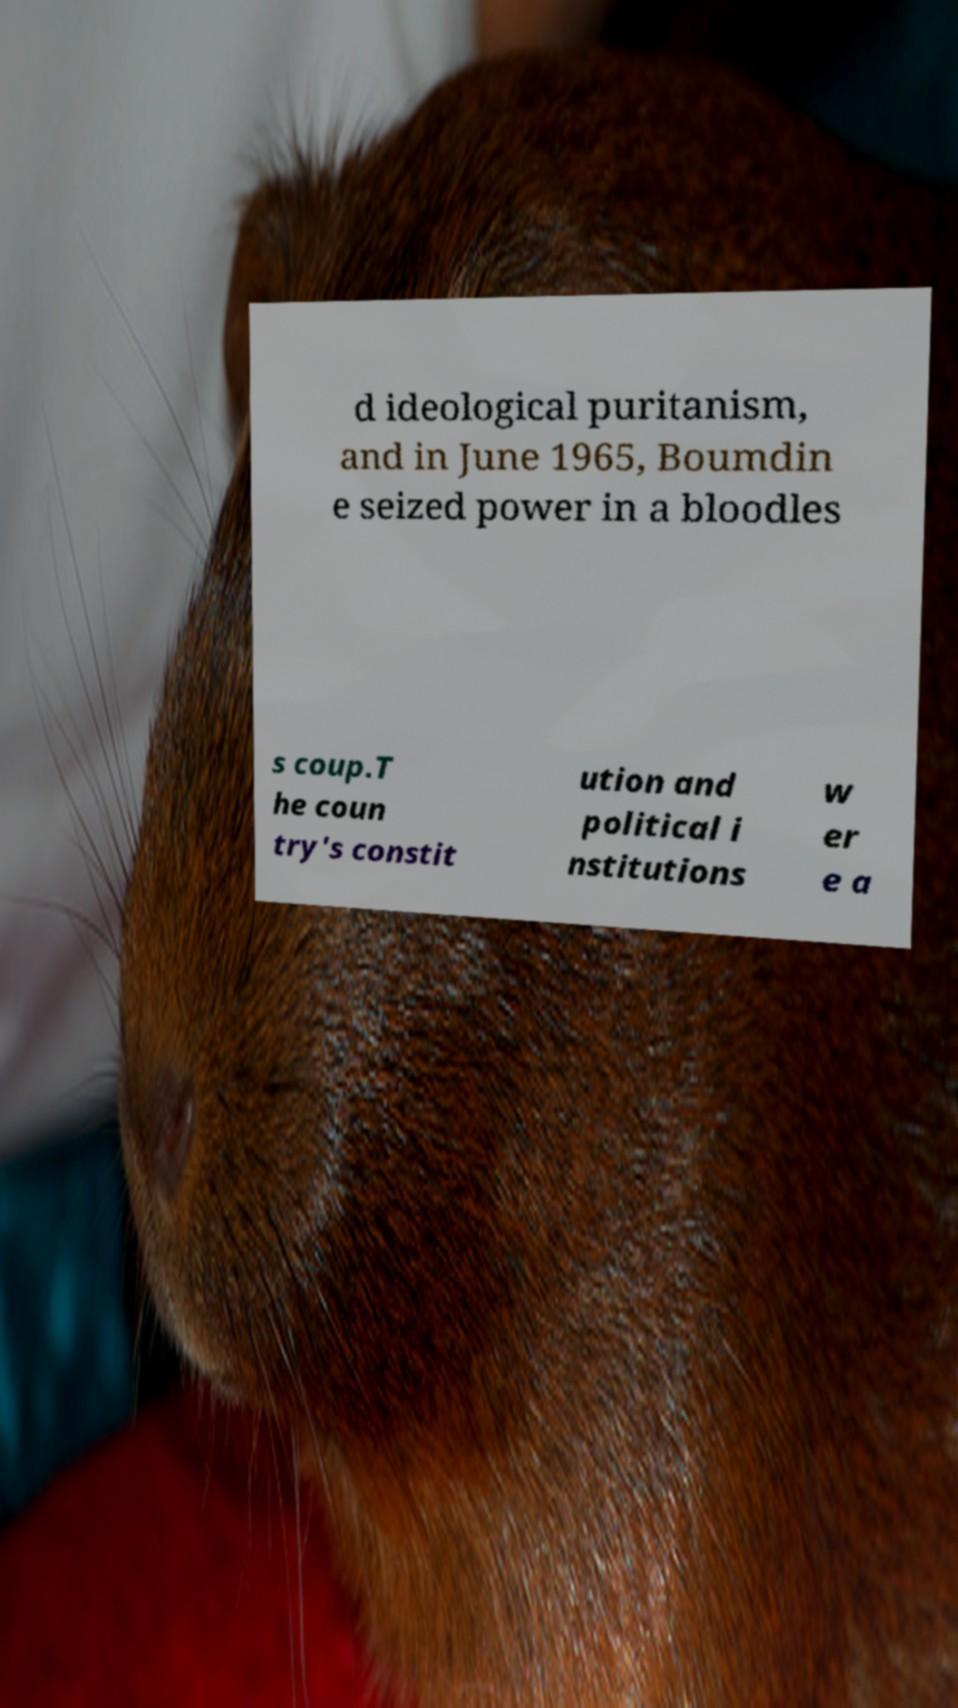Can you read and provide the text displayed in the image?This photo seems to have some interesting text. Can you extract and type it out for me? d ideological puritanism, and in June 1965, Boumdin e seized power in a bloodles s coup.T he coun try's constit ution and political i nstitutions w er e a 